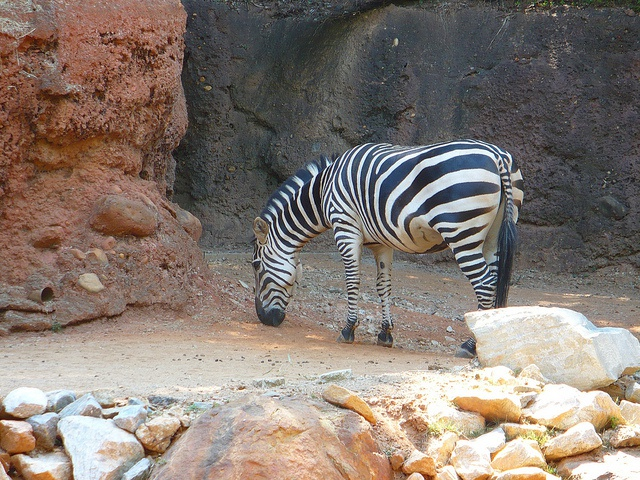Describe the objects in this image and their specific colors. I can see a zebra in tan, gray, lightgray, black, and darkgray tones in this image. 